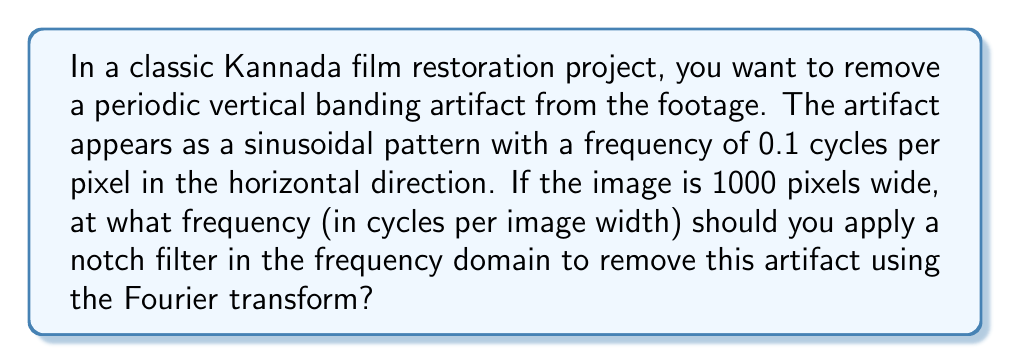Give your solution to this math problem. To solve this problem, we need to understand how the Fourier transform relates spatial frequencies in the image to frequencies in the transform domain:

1. The artifact frequency is given as 0.1 cycles per pixel.

2. The image width is 1000 pixels.

3. To convert from cycles per pixel to cycles per image width:
   $$ f_{image} = f_{pixel} \times \text{image width} $$

4. Substituting the values:
   $$ f_{image} = 0.1 \text{ cycles/pixel} \times 1000 \text{ pixels} $$
   $$ f_{image} = 100 \text{ cycles/image width} $$

5. In the frequency domain of the Fourier transform, this artifact will appear as a peak at 100 cycles per image width.

6. To remove the artifact, we need to apply a notch filter at this frequency in the Fourier domain.
Answer: The notch filter should be applied at a frequency of 100 cycles per image width in the Fourier domain. 